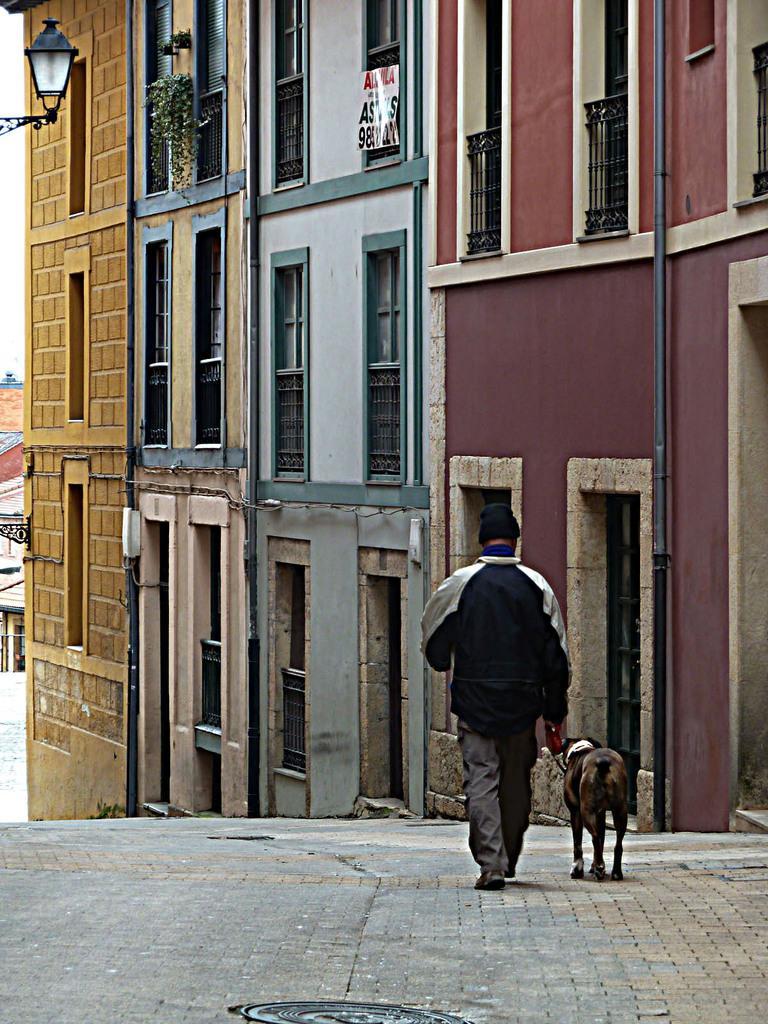Can you describe this image briefly? In this image I can see a man wearing a jacket and cap on his head and walking on the road. Beside this person there is a dog is also walking. In the background I can see a building. 